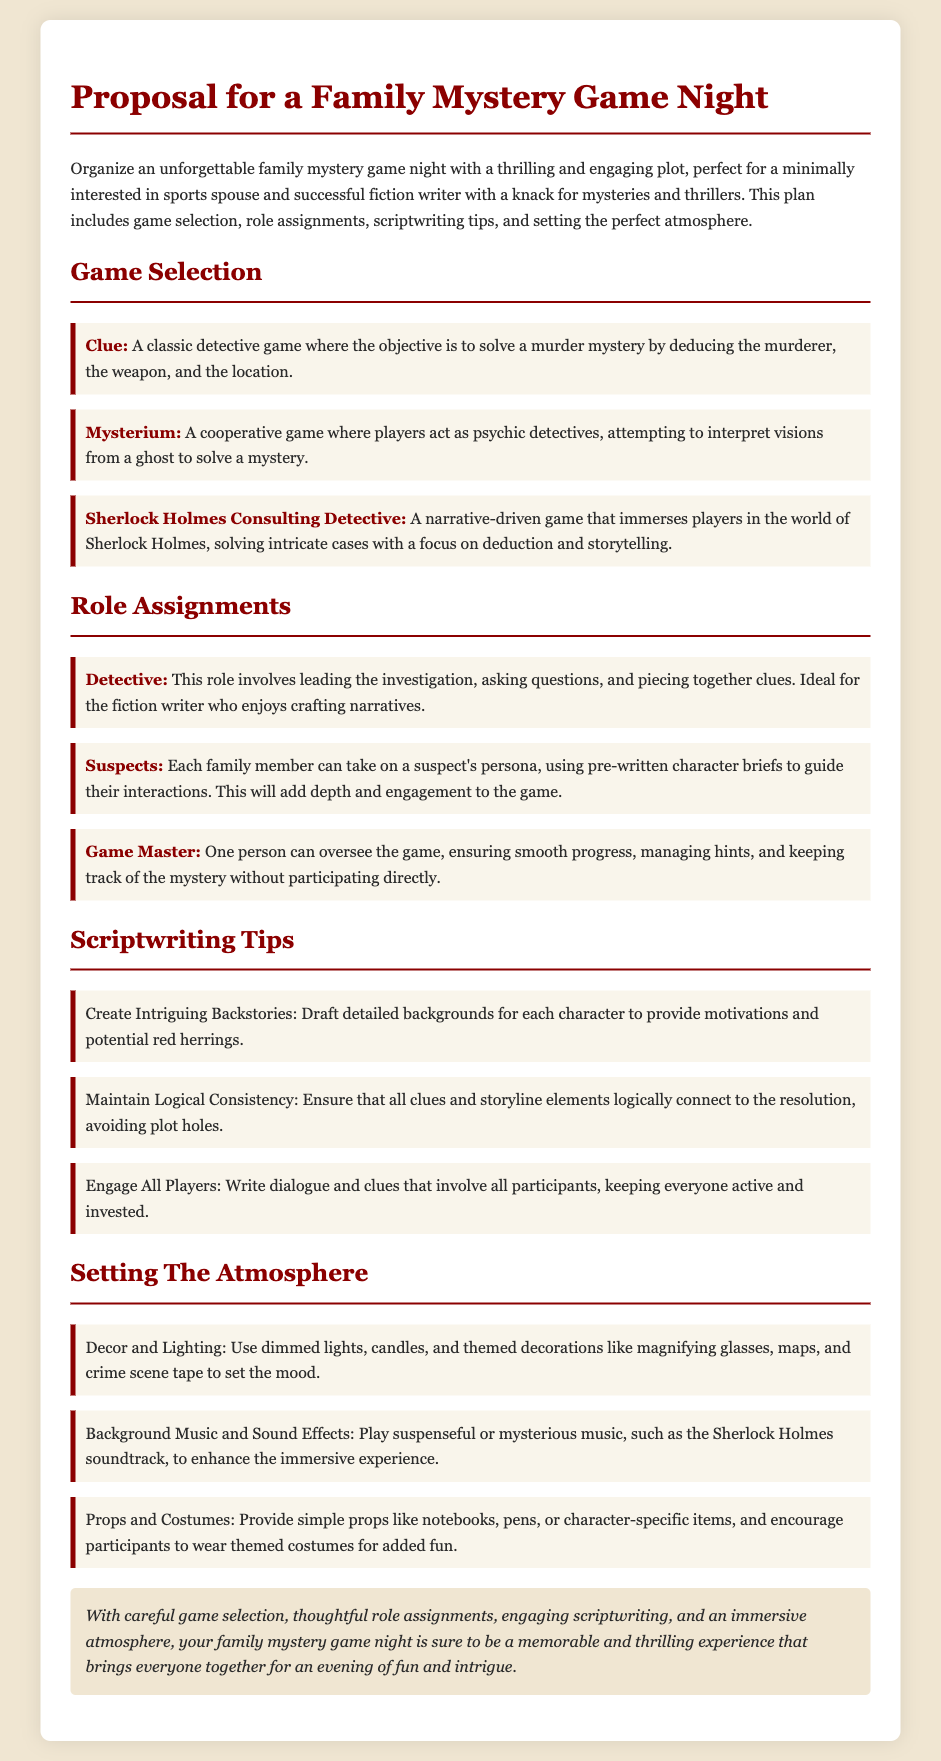What is the title of the proposal? The title of the proposal is stated in the document header.
Answer: Proposal for a Family Mystery Game Night How many games are listed under Game Selection? There are three games mentioned in the Game Selection section of the document.
Answer: 3 Which role involves leading the investigation? The role that leads the investigation is clearly mentioned in the Role Assignments section.
Answer: Detective What is one of the scriptwriting tips provided? The document lists several tips under Scriptwriting Tips.
Answer: Create Intriguing Backstories What type of music should be played to enhance the atmosphere? The document specifies the type of background music suitable for the atmosphere in the Setting The Atmosphere section.
Answer: Suspenseful or mysterious music Who oversees the game without participating directly? The document specifies a role that ensures smooth progress without direct participation.
Answer: Game Master Which game is described as a narrative-driven experience? The document characterizes one specific game in the Game Selection section.
Answer: Sherlock Holmes Consulting Detective What is suggested for setting the mood in terms of decor? The Setting The Atmosphere section provides specific recommendations for creating the right mood.
Answer: Dimmed lights and candles 